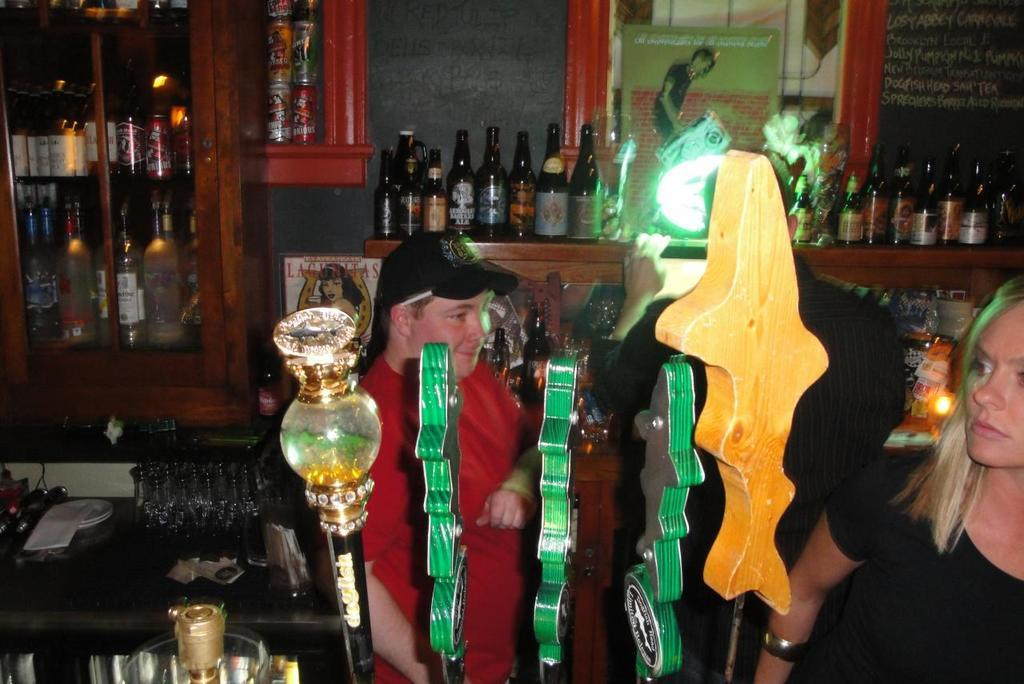How many people are present in the image? There is a man and a woman in the image. What can be seen in the background of the image? There are bottles on a rack and in a cupboard in the background. What type of boot is the man wearing in the image? There is no boot visible in the image; the man is not wearing any footwear. 